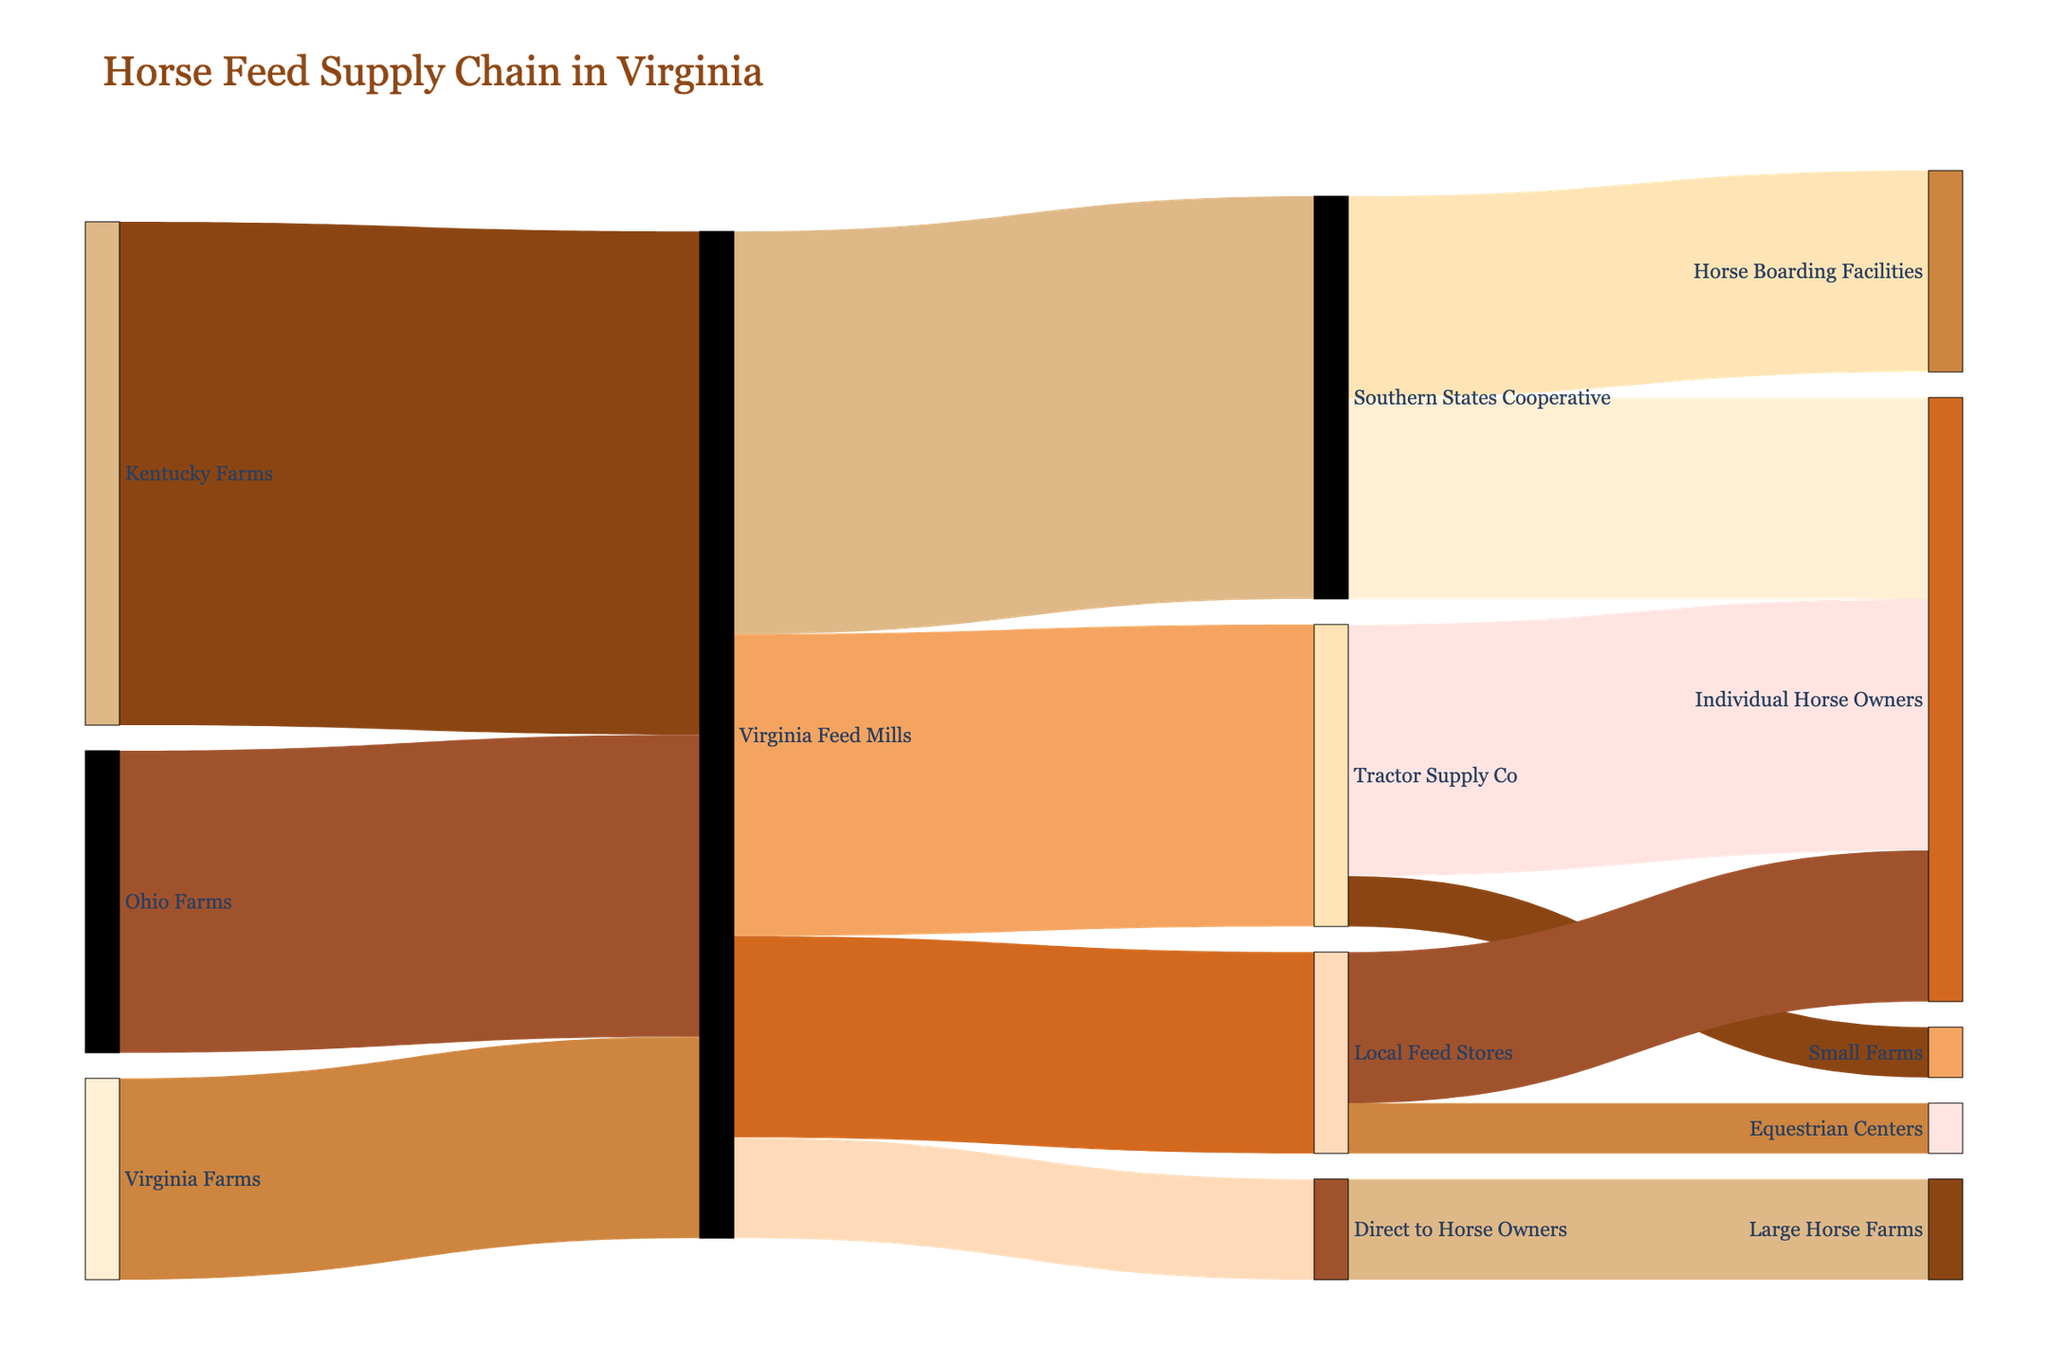What's the title of the figure? The title of the figure is usually prominently displayed at the top. In this case, it specifies the overall topic of the diagram.
Answer: Horse Feed Supply Chain in Virginia Which source provides the most feed to Virginia Feed Mills? By looking at the widths of the flows leading to Virginia Feed Mills, the one from Kentucky Farms is the widest, indicating the largest supply.
Answer: Kentucky Farms How much feed do small farms receive from Tractor Supply Co? By following the flow from Tractor Supply Co to small farms, the value indicates the quantity of feed.
Answer: 500 What is the total amount of feed produced by Virginia Farms? Follow the flow starting from Virginia Farms to Virginia Feed Mills and read the value.
Answer: 2000 What is the combined total feed provided to horse owners from various sources? Add the values from each source leading to individual horse owners: Southern States Cooperative (2000) + Tractor Supply Co (2500) + Local Feed Stores (1500).
Answer: 6000 Which organization or store receives the least feed from Virginia Feed Mills? By comparing the values of feed received by each target from Virginia Feed Mills, the smallest flow is to Direct to Horse Owners.
Answer: Direct to Horse Owners What is the difference in feed supplied between Kentucky Farms and Ohio Farms to Virginia Feed Mills? Subtract the amount of feed supplied by Ohio Farms (3000) from the amount supplied by Kentucky Farms (5000).
Answer: 2000 How does the feed supply to Equestrian Centers compare to that to Large Horse Farms? Compare the values from Local Feed Stores to Equestrian Centers (500) and from Direct to Horse Owners to Large Horse Farms (1000).
Answer: Equestrian Centers receive 500 less than Large Horse Farms What is the total amount of feed distributed by the Virginia Feed Mills? Sum the values of all the distributions from the Virginia Feed Mills: Southern States Cooperative (4000) + Tractor Supply Co (3000) + Local Feed Stores (2000) + Direct to Horse Owners (1000).
Answer: 10000 What color represents Kentucky Farms in the diagram? Kentucky Farms is the first node in the diagram. Colors are assigned starting from the first node sequentially from the custom color palette.
Answer: Brown (assumed '#8B4513' based on placement in the code) 